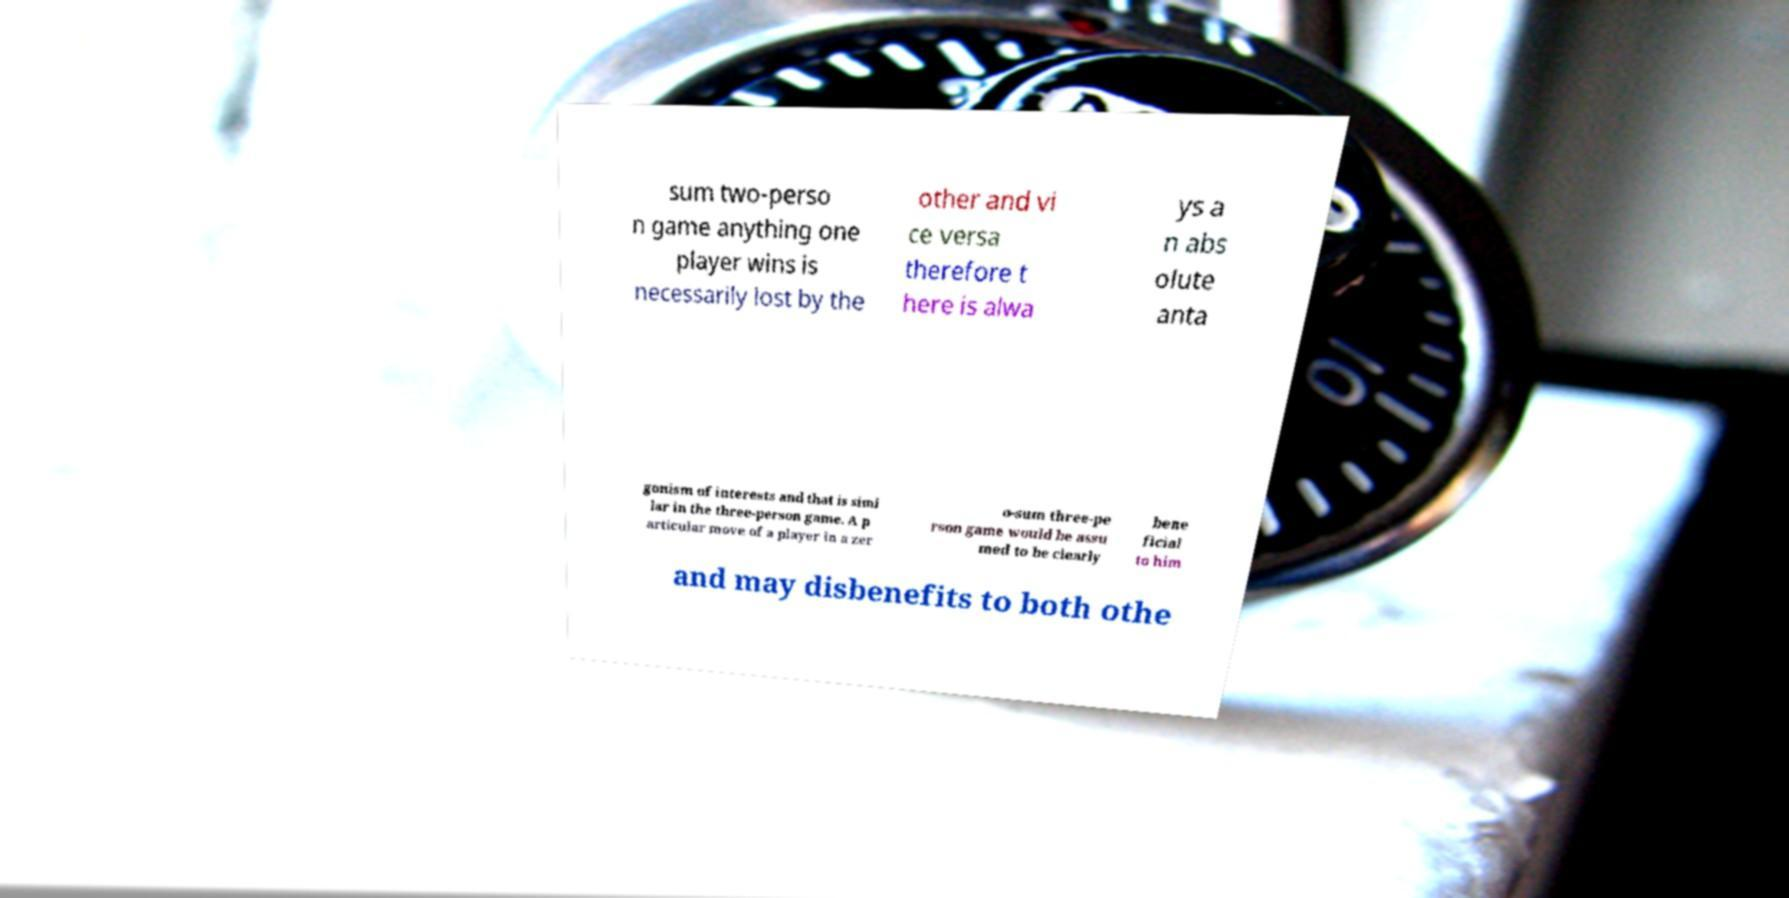Could you extract and type out the text from this image? sum two-perso n game anything one player wins is necessarily lost by the other and vi ce versa therefore t here is alwa ys a n abs olute anta gonism of interests and that is simi lar in the three-person game. A p articular move of a player in a zer o-sum three-pe rson game would be assu med to be clearly bene ficial to him and may disbenefits to both othe 